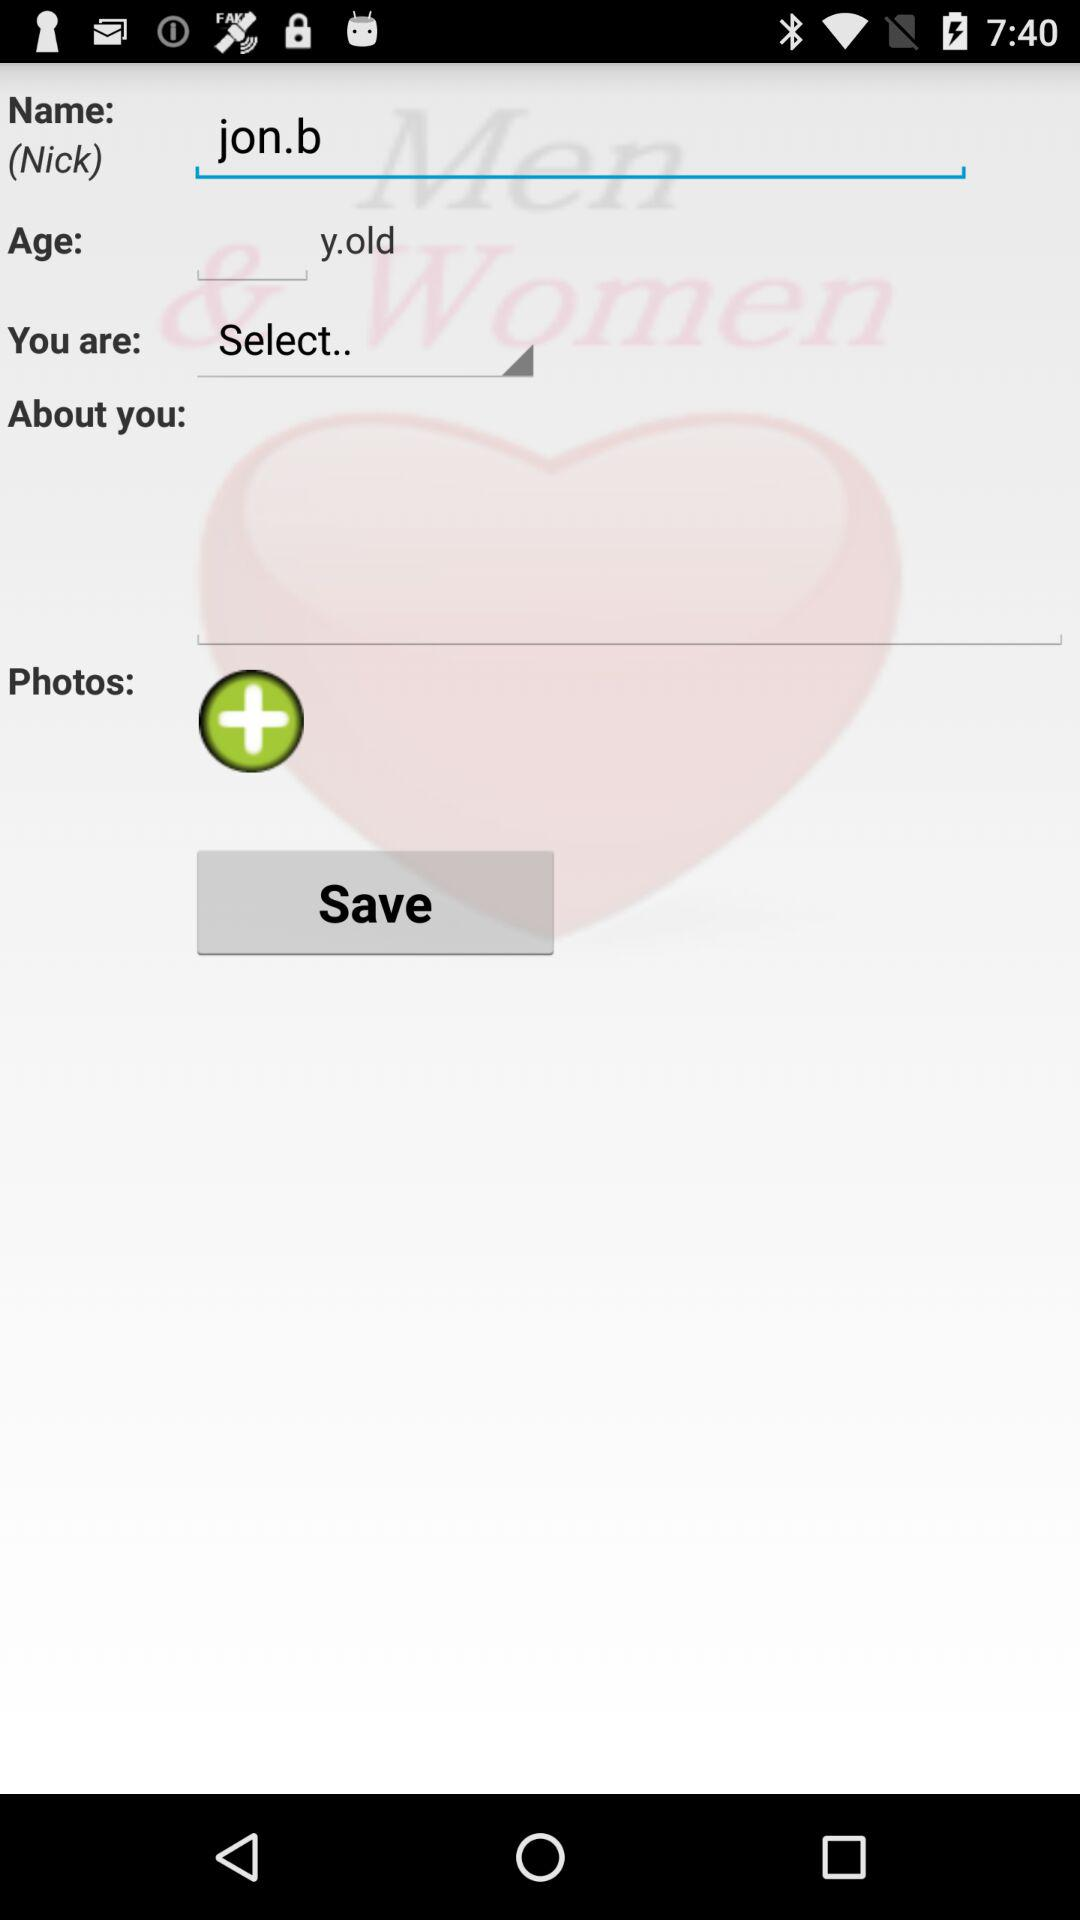How old is Jon?
When the provided information is insufficient, respond with <no answer>. <no answer> 